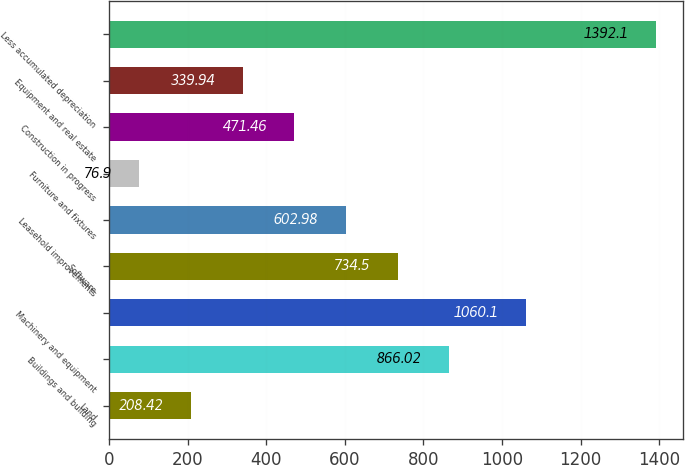<chart> <loc_0><loc_0><loc_500><loc_500><bar_chart><fcel>Land<fcel>Buildings and building<fcel>Machinery and equipment<fcel>Software<fcel>Leasehold improvements<fcel>Furniture and fixtures<fcel>Construction in progress<fcel>Equipment and real estate<fcel>Less accumulated depreciation<nl><fcel>208.42<fcel>866.02<fcel>1060.1<fcel>734.5<fcel>602.98<fcel>76.9<fcel>471.46<fcel>339.94<fcel>1392.1<nl></chart> 